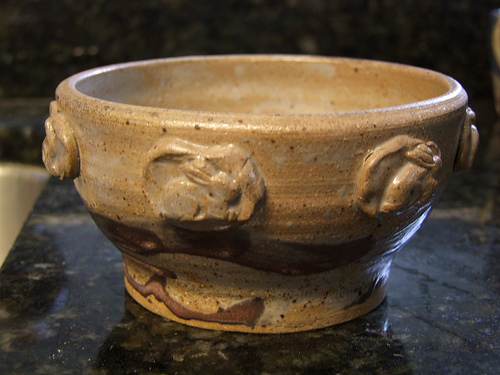<image>
Can you confirm if the bunny is on the bowl? Yes. Looking at the image, I can see the bunny is positioned on top of the bowl, with the bowl providing support. 